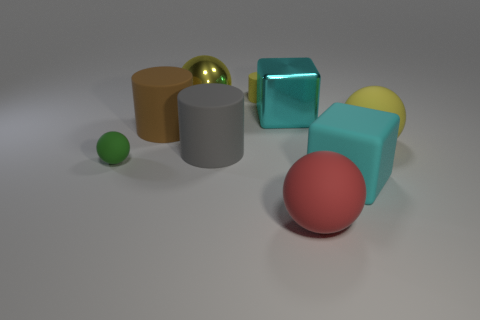Subtract all tiny green balls. How many balls are left? 3 Add 1 small gray things. How many objects exist? 10 Subtract all green balls. How many balls are left? 3 Subtract 2 balls. How many balls are left? 2 Subtract all cyan balls. Subtract all purple blocks. How many balls are left? 4 Subtract all balls. How many objects are left? 5 Subtract all shiny cubes. Subtract all cyan shiny objects. How many objects are left? 7 Add 5 large yellow rubber spheres. How many large yellow rubber spheres are left? 6 Add 3 blue rubber blocks. How many blue rubber blocks exist? 3 Subtract 1 cyan cubes. How many objects are left? 8 